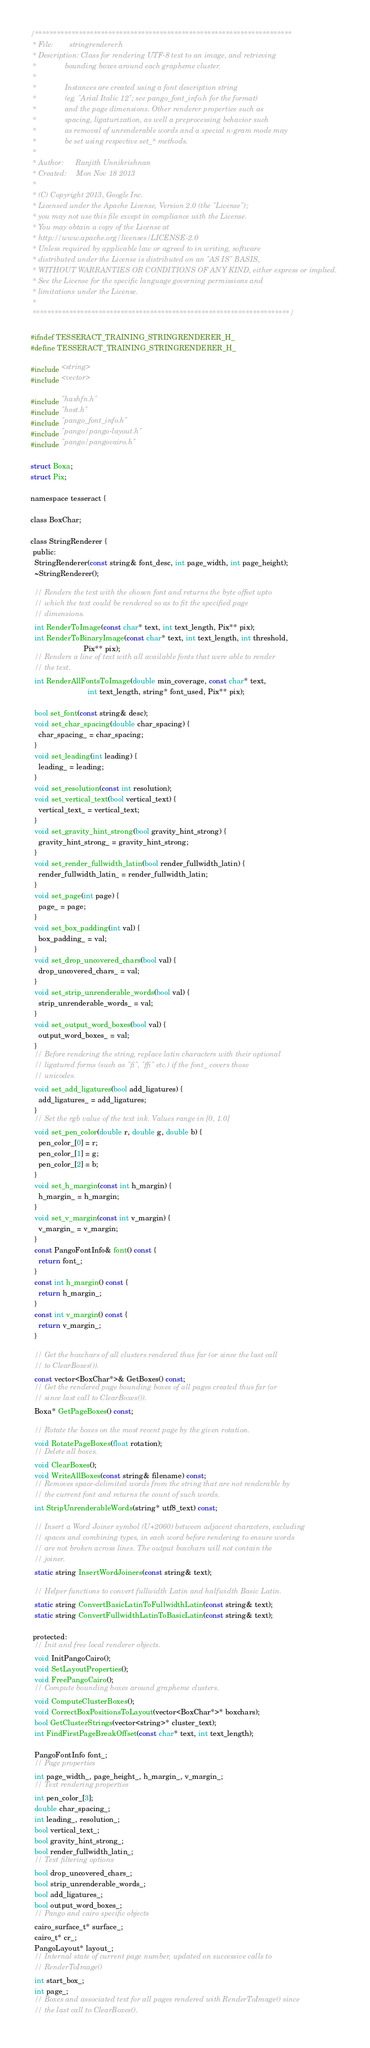<code> <loc_0><loc_0><loc_500><loc_500><_C_>/**********************************************************************
 * File:        stringrenderer.h
 * Description: Class for rendering UTF-8 text to an image, and retrieving
 *              bounding boxes around each grapheme cluster.
 *
 *              Instances are created using a font description string
 *              (eg. "Arial Italic 12"; see pango_font_info.h for the format)
 *              and the page dimensions. Other renderer properties such as
 *              spacing, ligaturization, as well a preprocessing behavior such
 *              as removal of unrenderable words and a special n-gram mode may
 *              be set using respective set_* methods.
 *
 * Author:      Ranjith Unnikrishnan
 * Created:     Mon Nov 18 2013
 *
 * (C) Copyright 2013, Google Inc.
 * Licensed under the Apache License, Version 2.0 (the "License");
 * you may not use this file except in compliance with the License.
 * You may obtain a copy of the License at
 * http://www.apache.org/licenses/LICENSE-2.0
 * Unless required by applicable law or agreed to in writing, software
 * distributed under the License is distributed on an "AS IS" BASIS,
 * WITHOUT WARRANTIES OR CONDITIONS OF ANY KIND, either express or implied.
 * See the License for the specific language governing permissions and
 * limitations under the License.
 *
 **********************************************************************/

#ifndef TESSERACT_TRAINING_STRINGRENDERER_H_
#define TESSERACT_TRAINING_STRINGRENDERER_H_

#include <string>
#include <vector>

#include "hashfn.h"
#include "host.h"
#include "pango_font_info.h"
#include "pango/pango-layout.h"
#include "pango/pangocairo.h"

struct Boxa;
struct Pix;

namespace tesseract {

class BoxChar;

class StringRenderer {
 public:
  StringRenderer(const string& font_desc, int page_width, int page_height);
  ~StringRenderer();

  // Renders the text with the chosen font and returns the byte offset upto
  // which the text could be rendered so as to fit the specified page
  // dimensions.
  int RenderToImage(const char* text, int text_length, Pix** pix);
  int RenderToBinaryImage(const char* text, int text_length, int threshold,
                          Pix** pix);
  // Renders a line of text with all available fonts that were able to render
  // the text.
  int RenderAllFontsToImage(double min_coverage, const char* text,
                            int text_length, string* font_used, Pix** pix);

  bool set_font(const string& desc);
  void set_char_spacing(double char_spacing) {
    char_spacing_ = char_spacing;
  }
  void set_leading(int leading) {
    leading_ = leading;
  }
  void set_resolution(const int resolution);
  void set_vertical_text(bool vertical_text) {
    vertical_text_ = vertical_text;
  }
  void set_gravity_hint_strong(bool gravity_hint_strong) {
    gravity_hint_strong_ = gravity_hint_strong;
  }
  void set_render_fullwidth_latin(bool render_fullwidth_latin) {
    render_fullwidth_latin_ = render_fullwidth_latin;
  }
  void set_page(int page) {
    page_ = page;
  }
  void set_box_padding(int val) {
    box_padding_ = val;
  }
  void set_drop_uncovered_chars(bool val) {
    drop_uncovered_chars_ = val;
  }
  void set_strip_unrenderable_words(bool val) {
    strip_unrenderable_words_ = val;
  }
  void set_output_word_boxes(bool val) {
    output_word_boxes_ = val;
  }
  // Before rendering the string, replace latin characters with their optional
  // ligatured forms (such as "fi", "ffi" etc.) if the font_ covers those
  // unicodes.
  void set_add_ligatures(bool add_ligatures) {
    add_ligatures_ = add_ligatures;
  }
  // Set the rgb value of the text ink. Values range in [0, 1.0]
  void set_pen_color(double r, double g, double b) {
    pen_color_[0] = r;
    pen_color_[1] = g;
    pen_color_[2] = b;
  }
  void set_h_margin(const int h_margin) {
    h_margin_ = h_margin;
  }
  void set_v_margin(const int v_margin) {
    v_margin_ = v_margin;
  }
  const PangoFontInfo& font() const {
    return font_;
  }
  const int h_margin() const {
    return h_margin_;
  }
  const int v_margin() const {
    return v_margin_;
  }

  // Get the boxchars of all clusters rendered thus far (or since the last call
  // to ClearBoxes()).
  const vector<BoxChar*>& GetBoxes() const;
  // Get the rendered page bounding boxes of all pages created thus far (or
  // since last call to ClearBoxes()).
  Boxa* GetPageBoxes() const;

  // Rotate the boxes on the most recent page by the given rotation.
  void RotatePageBoxes(float rotation);
  // Delete all boxes.
  void ClearBoxes();
  void WriteAllBoxes(const string& filename) const;
  // Removes space-delimited words from the string that are not renderable by
  // the current font and returns the count of such words.
  int StripUnrenderableWords(string* utf8_text) const;

  // Insert a Word Joiner symbol (U+2060) between adjacent characters, excluding
  // spaces and combining types, in each word before rendering to ensure words
  // are not broken across lines. The output boxchars will not contain the
  // joiner.
  static string InsertWordJoiners(const string& text);

  // Helper functions to convert fullwidth Latin and halfwidth Basic Latin.
  static string ConvertBasicLatinToFullwidthLatin(const string& text);
  static string ConvertFullwidthLatinToBasicLatin(const string& text);

 protected:
  // Init and free local renderer objects.
  void InitPangoCairo();
  void SetLayoutProperties();
  void FreePangoCairo();
  // Compute bounding boxes around grapheme clusters.
  void ComputeClusterBoxes();
  void CorrectBoxPositionsToLayout(vector<BoxChar*>* boxchars);
  bool GetClusterStrings(vector<string>* cluster_text);
  int FindFirstPageBreakOffset(const char* text, int text_length);

  PangoFontInfo font_;
  // Page properties
  int page_width_, page_height_, h_margin_, v_margin_;
  // Text rendering properties
  int pen_color_[3];
  double char_spacing_;
  int leading_, resolution_;
  bool vertical_text_;
  bool gravity_hint_strong_;
  bool render_fullwidth_latin_;
  // Text filtering options
  bool drop_uncovered_chars_;
  bool strip_unrenderable_words_;
  bool add_ligatures_;
  bool output_word_boxes_;
  // Pango and cairo specific objects
  cairo_surface_t* surface_;
  cairo_t* cr_;
  PangoLayout* layout_;
  // Internal state of current page number, updated on successive calls to
  // RenderToImage()
  int start_box_;
  int page_;
  // Boxes and associated text for all pages rendered with RenderToImage() since
  // the last call to ClearBoxes().</code> 